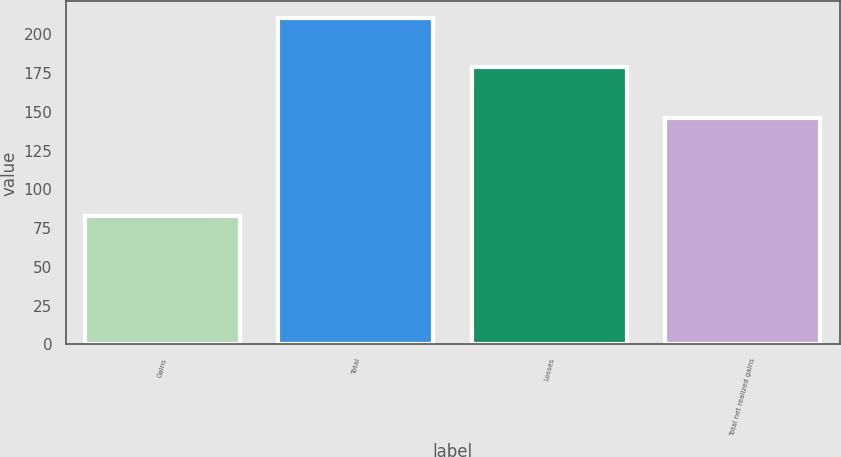Convert chart. <chart><loc_0><loc_0><loc_500><loc_500><bar_chart><fcel>Gains<fcel>Total<fcel>Losses<fcel>Total net realized gains<nl><fcel>82.6<fcel>210.9<fcel>179.1<fcel>146.1<nl></chart> 